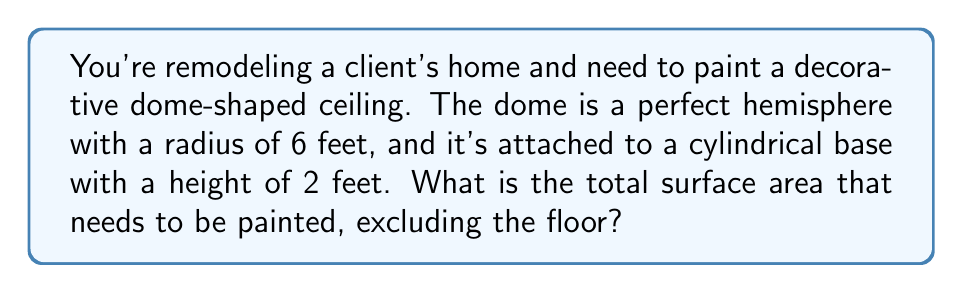Teach me how to tackle this problem. Let's break this down step-by-step:

1. Calculate the surface area of the hemisphere:
   The surface area of a hemisphere is given by $2\pi r^2$
   $$A_{hemisphere} = 2\pi r^2 = 2\pi (6 \text{ ft})^2 = 72\pi \text{ ft}^2$$

2. Calculate the surface area of the cylindrical walls:
   The surface area of a cylinder (excluding top and bottom) is given by $2\pi rh$
   $$A_{cylinder} = 2\pi rh = 2\pi (6 \text{ ft})(2 \text{ ft}) = 24\pi \text{ ft}^2$$

3. Sum up the total surface area:
   $$A_{total} = A_{hemisphere} + A_{cylinder} = 72\pi \text{ ft}^2 + 24\pi \text{ ft}^2 = 96\pi \text{ ft}^2$$

4. Simplify the result:
   $$A_{total} = 96\pi \text{ ft}^2 \approx 301.59 \text{ ft}^2$$

Therefore, the total surface area that needs to be painted is approximately 301.59 square feet.
Answer: $96\pi \text{ ft}^2$ or approximately 301.59 ft² 